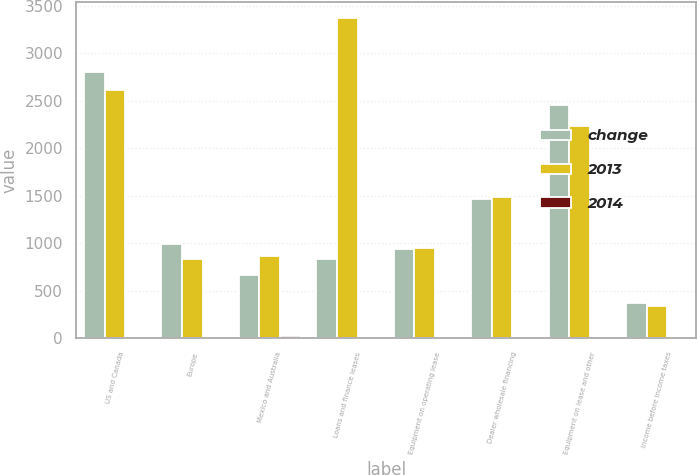Convert chart. <chart><loc_0><loc_0><loc_500><loc_500><stacked_bar_chart><ecel><fcel>US and Canada<fcel>Europe<fcel>Mexico and Australia<fcel>Loans and finance leases<fcel>Equipment on operating lease<fcel>Dealer wholesale financing<fcel>Equipment on lease and other<fcel>Income before income taxes<nl><fcel>change<fcel>2798.3<fcel>988.1<fcel>668.7<fcel>838.3<fcel>938.4<fcel>1462<fcel>2452.9<fcel>370.4<nl><fcel>2013<fcel>2617.4<fcel>838.3<fcel>862.9<fcel>3368.1<fcel>950.5<fcel>1490.9<fcel>2230.7<fcel>340.2<nl><fcel>2014<fcel>7<fcel>18<fcel>23<fcel>4<fcel>1<fcel>2<fcel>10<fcel>9<nl></chart> 